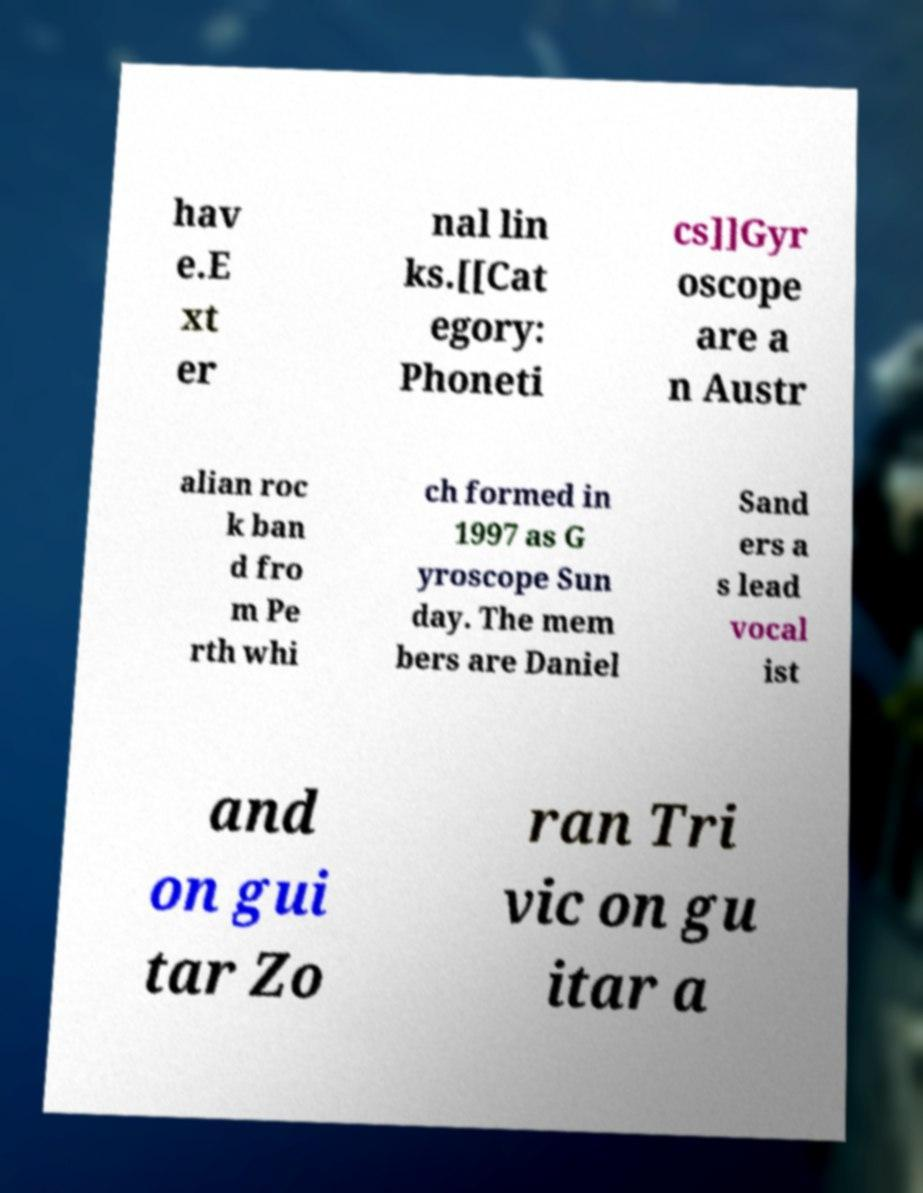Can you read and provide the text displayed in the image?This photo seems to have some interesting text. Can you extract and type it out for me? hav e.E xt er nal lin ks.[[Cat egory: Phoneti cs]]Gyr oscope are a n Austr alian roc k ban d fro m Pe rth whi ch formed in 1997 as G yroscope Sun day. The mem bers are Daniel Sand ers a s lead vocal ist and on gui tar Zo ran Tri vic on gu itar a 